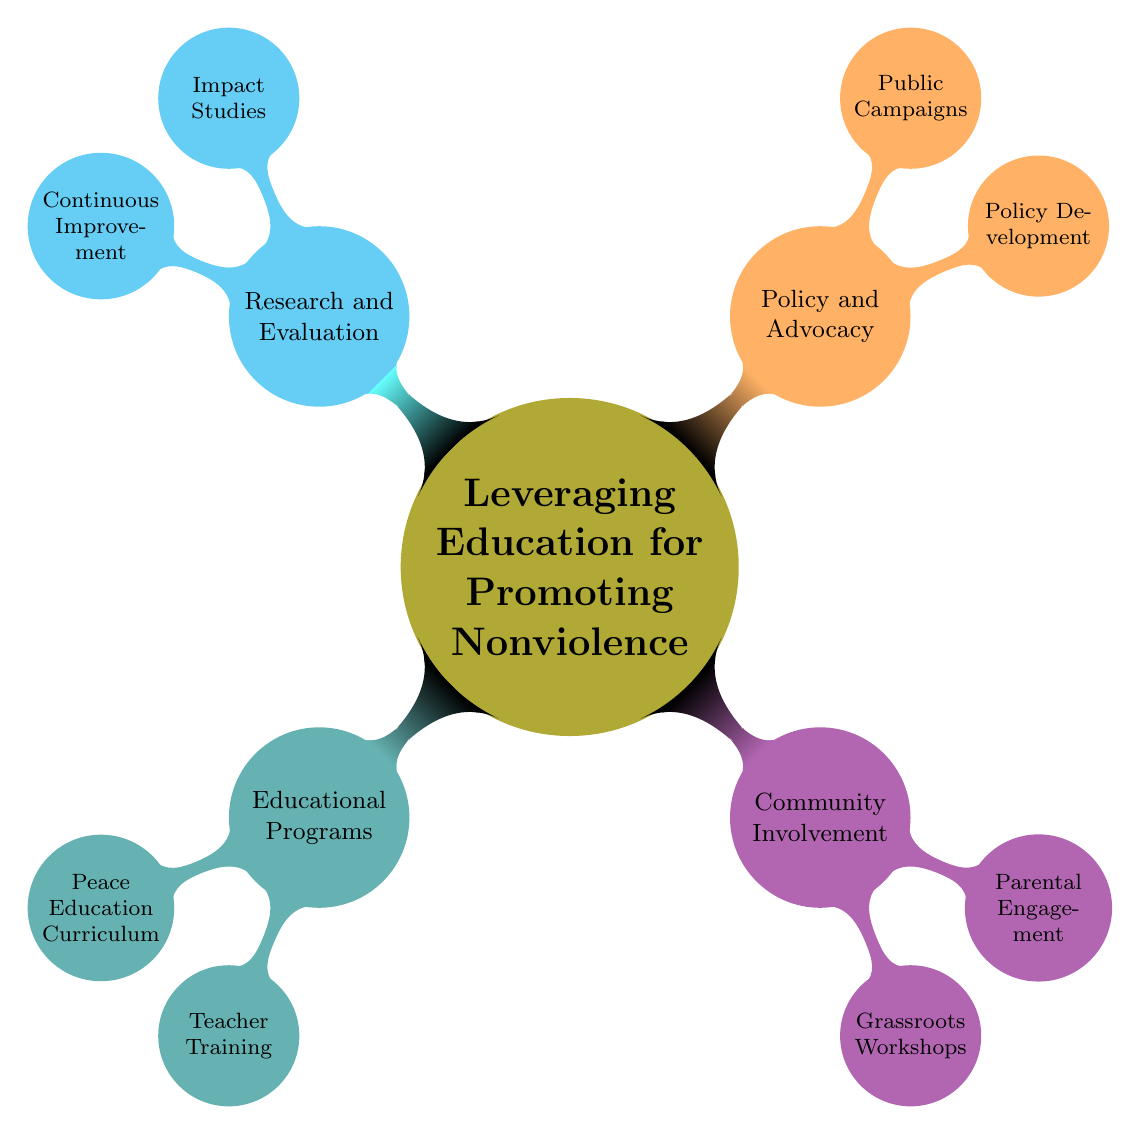What is the main topic of the mind map? The main topic is prominently displayed as the central node of the diagram, which is "Leveraging Education for Promoting Nonviolence".
Answer: Leveraging Education for Promoting Nonviolence How many subtopics are there under the main topic? Counting the nodes branching directly from the main topic, there are four subtopics: Educational Programs, Community Involvement, Policy and Advocacy, Research and Evaluation.
Answer: 4 What is one example of an organization involved in teacher training? By looking at the node under the Educational Programs subtopic labeled Teacher Training, one organization mentioned is "Teachers Without Borders".
Answer: Teachers Without Borders Which subtopic contains Grassroots Workshops? Grassroots Workshops are categorized under the Community Involvement subtopic, which is highlighted in a specific color in the diagram.
Answer: Community Involvement What type of studies are included in the Research and Evaluation subtopic? Within the Research and Evaluation subtopic, the Impact Studies represent one of the types of studies that are mentioned.
Answer: Impact Studies What method is associated with grassroots workshops? The diagram specifies that one method associated with grassroots workshops is "Interactive Discussions".
Answer: Interactive Discussions Which two subtopics focus on community and parental aspects? The Community Involvement subtopic, which includes Grassroots Workshops and Parental Engagement, directly emphasizes community and parental involvement.
Answer: Community Involvement and Parental Engagement How many organizations are mentioned under the Public Campaigns subtopic? The Public Campaigns subtopic features two organizations: "Amnesty International" and "Global Movement for Nonviolence".
Answer: 2 What is one focus area for parental engagement? The Parental Engagement node highlights "Nonviolent Communication Skills" as one of its focus areas.
Answer: Nonviolent Communication Skills Which subtopic includes metrics for evaluation? The Research and Evaluation subtopic includes the specific node that mentions metrics as part of the evaluation process, emphasizing its role in assessing impact.
Answer: Research and Evaluation 